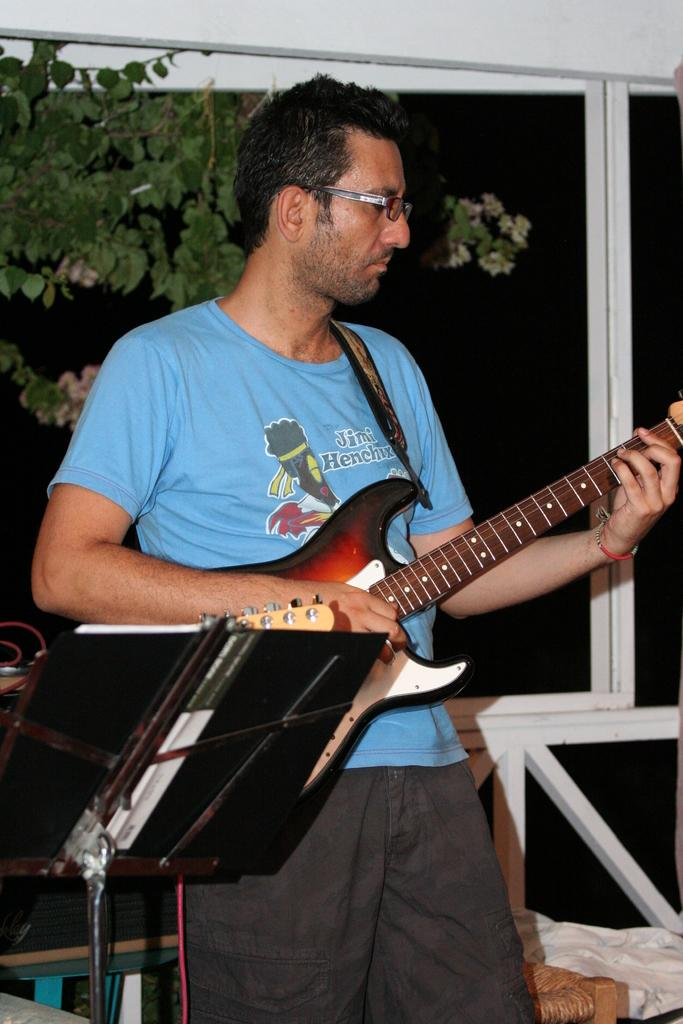What is the man in the image doing? The man is playing a guitar. How is the man positioned in the image? The man is standing. What can be seen in the background of the image? There is a railing and a tree in the background of the image. What type of company is the man representing in the image? There is no indication in the image that the man is representing a company. What religion is the man practicing in the image? There is no indication in the image that the man is practicing any religion. 